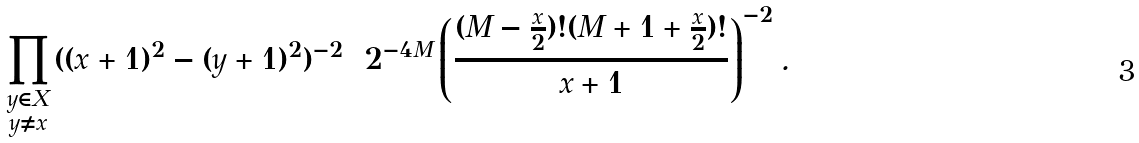Convert formula to latex. <formula><loc_0><loc_0><loc_500><loc_500>\prod _ { \begin{smallmatrix} y \in X \\ y \neq x \end{smallmatrix} } ( ( x + 1 ) ^ { 2 } - ( y + 1 ) ^ { 2 } ) ^ { - 2 } = 2 ^ { - 4 M } \left ( \frac { ( M - \frac { x } { 2 } ) ! ( M + 1 + \frac { x } { 2 } ) ! } { x + 1 } \right ) ^ { - 2 } .</formula> 